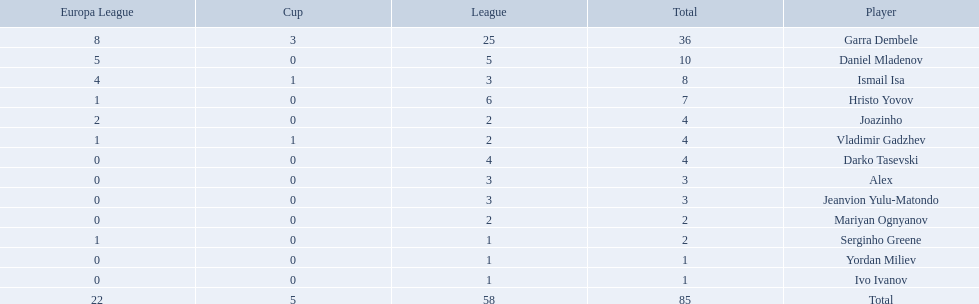What league is 2? 2, 2, 2. Which cup is less than 1? 0, 0. Which total is 2? 2. Who is the player? Mariyan Ognyanov. Who are all of the players? Garra Dembele, Daniel Mladenov, Ismail Isa, Hristo Yovov, Joazinho, Vladimir Gadzhev, Darko Tasevski, Alex, Jeanvion Yulu-Matondo, Mariyan Ognyanov, Serginho Greene, Yordan Miliev, Ivo Ivanov. And which league is each player in? 25, 5, 3, 6, 2, 2, 4, 3, 3, 2, 1, 1, 1. Along with vladimir gadzhev and joazinho, which other player is in league 2? Mariyan Ognyanov. 